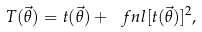Convert formula to latex. <formula><loc_0><loc_0><loc_500><loc_500>T ( \vec { \theta } ) = t ( \vec { \theta } ) + \ f n l [ t ( \vec { \theta } ) ] ^ { 2 } ,</formula> 